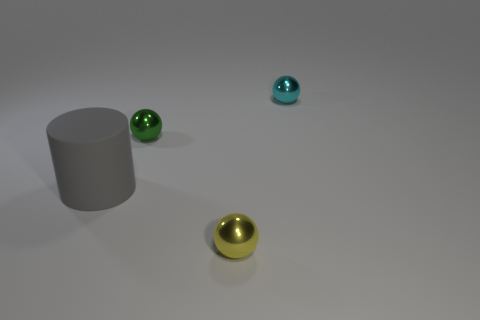Add 2 large brown spheres. How many objects exist? 6 Subtract all red cylinders. Subtract all yellow cubes. How many cylinders are left? 1 Subtract all cylinders. How many objects are left? 3 Add 3 tiny objects. How many tiny objects exist? 6 Subtract 0 purple spheres. How many objects are left? 4 Subtract all cyan spheres. Subtract all large blue things. How many objects are left? 3 Add 3 metallic spheres. How many metallic spheres are left? 6 